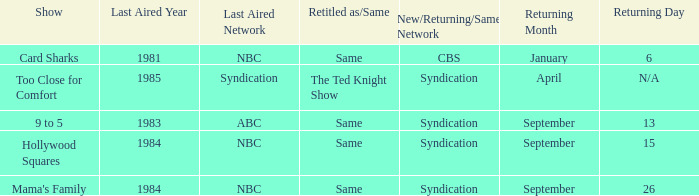When was the show 9 to 5 returning? September 13. 